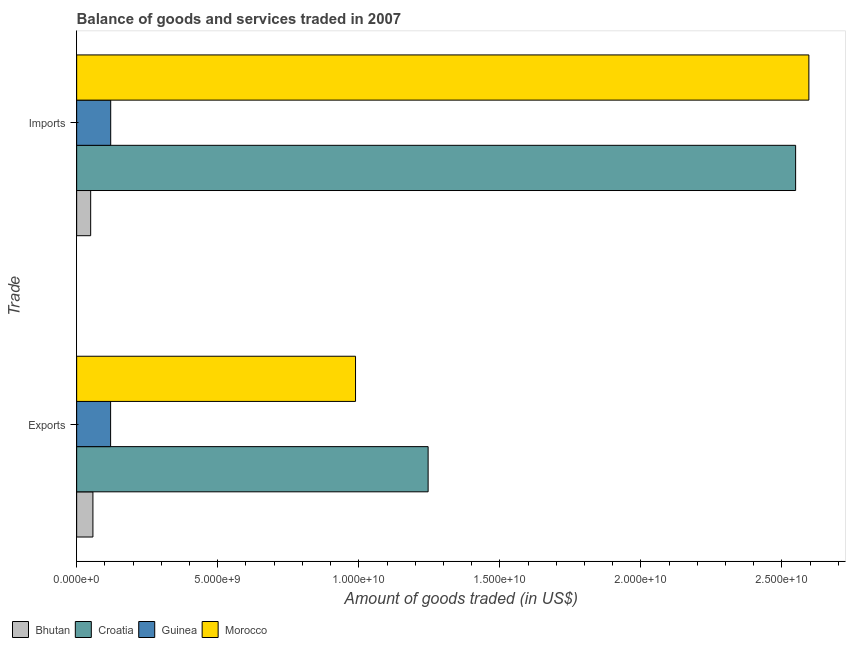How many different coloured bars are there?
Keep it short and to the point. 4. How many bars are there on the 2nd tick from the bottom?
Make the answer very short. 4. What is the label of the 1st group of bars from the top?
Provide a succinct answer. Imports. What is the amount of goods imported in Bhutan?
Make the answer very short. 4.97e+08. Across all countries, what is the maximum amount of goods exported?
Your answer should be compact. 1.25e+1. Across all countries, what is the minimum amount of goods exported?
Make the answer very short. 5.77e+08. In which country was the amount of goods imported maximum?
Provide a succinct answer. Morocco. In which country was the amount of goods imported minimum?
Keep it short and to the point. Bhutan. What is the total amount of goods imported in the graph?
Your answer should be very brief. 5.31e+1. What is the difference between the amount of goods exported in Bhutan and that in Morocco?
Your answer should be compact. -9.31e+09. What is the difference between the amount of goods imported in Guinea and the amount of goods exported in Bhutan?
Your answer should be very brief. 6.30e+08. What is the average amount of goods imported per country?
Offer a very short reply. 1.33e+1. What is the difference between the amount of goods imported and amount of goods exported in Guinea?
Your response must be concise. 3.24e+06. What is the ratio of the amount of goods imported in Guinea to that in Croatia?
Your answer should be compact. 0.05. Is the amount of goods exported in Croatia less than that in Guinea?
Ensure brevity in your answer.  No. What does the 2nd bar from the top in Exports represents?
Keep it short and to the point. Guinea. What does the 4th bar from the bottom in Exports represents?
Your answer should be very brief. Morocco. How many bars are there?
Make the answer very short. 8. How many countries are there in the graph?
Give a very brief answer. 4. What is the difference between two consecutive major ticks on the X-axis?
Your answer should be very brief. 5.00e+09. Does the graph contain grids?
Your answer should be compact. No. Where does the legend appear in the graph?
Your answer should be very brief. Bottom left. How many legend labels are there?
Keep it short and to the point. 4. What is the title of the graph?
Your response must be concise. Balance of goods and services traded in 2007. What is the label or title of the X-axis?
Ensure brevity in your answer.  Amount of goods traded (in US$). What is the label or title of the Y-axis?
Ensure brevity in your answer.  Trade. What is the Amount of goods traded (in US$) in Bhutan in Exports?
Provide a short and direct response. 5.77e+08. What is the Amount of goods traded (in US$) in Croatia in Exports?
Provide a succinct answer. 1.25e+1. What is the Amount of goods traded (in US$) of Guinea in Exports?
Offer a terse response. 1.20e+09. What is the Amount of goods traded (in US$) in Morocco in Exports?
Your answer should be very brief. 9.88e+09. What is the Amount of goods traded (in US$) in Bhutan in Imports?
Provide a succinct answer. 4.97e+08. What is the Amount of goods traded (in US$) in Croatia in Imports?
Your answer should be compact. 2.55e+1. What is the Amount of goods traded (in US$) of Guinea in Imports?
Your answer should be very brief. 1.21e+09. What is the Amount of goods traded (in US$) of Morocco in Imports?
Give a very brief answer. 2.60e+1. Across all Trade, what is the maximum Amount of goods traded (in US$) of Bhutan?
Ensure brevity in your answer.  5.77e+08. Across all Trade, what is the maximum Amount of goods traded (in US$) of Croatia?
Provide a short and direct response. 2.55e+1. Across all Trade, what is the maximum Amount of goods traded (in US$) of Guinea?
Give a very brief answer. 1.21e+09. Across all Trade, what is the maximum Amount of goods traded (in US$) of Morocco?
Your answer should be very brief. 2.60e+1. Across all Trade, what is the minimum Amount of goods traded (in US$) of Bhutan?
Offer a very short reply. 4.97e+08. Across all Trade, what is the minimum Amount of goods traded (in US$) in Croatia?
Make the answer very short. 1.25e+1. Across all Trade, what is the minimum Amount of goods traded (in US$) of Guinea?
Your answer should be compact. 1.20e+09. Across all Trade, what is the minimum Amount of goods traded (in US$) of Morocco?
Your answer should be very brief. 9.88e+09. What is the total Amount of goods traded (in US$) in Bhutan in the graph?
Your response must be concise. 1.07e+09. What is the total Amount of goods traded (in US$) of Croatia in the graph?
Offer a terse response. 3.79e+1. What is the total Amount of goods traded (in US$) in Guinea in the graph?
Offer a terse response. 2.41e+09. What is the total Amount of goods traded (in US$) in Morocco in the graph?
Your answer should be compact. 3.58e+1. What is the difference between the Amount of goods traded (in US$) of Bhutan in Exports and that in Imports?
Make the answer very short. 7.97e+07. What is the difference between the Amount of goods traded (in US$) in Croatia in Exports and that in Imports?
Your response must be concise. -1.30e+1. What is the difference between the Amount of goods traded (in US$) in Guinea in Exports and that in Imports?
Your response must be concise. -3.24e+06. What is the difference between the Amount of goods traded (in US$) in Morocco in Exports and that in Imports?
Your response must be concise. -1.61e+1. What is the difference between the Amount of goods traded (in US$) in Bhutan in Exports and the Amount of goods traded (in US$) in Croatia in Imports?
Your answer should be compact. -2.49e+1. What is the difference between the Amount of goods traded (in US$) of Bhutan in Exports and the Amount of goods traded (in US$) of Guinea in Imports?
Keep it short and to the point. -6.30e+08. What is the difference between the Amount of goods traded (in US$) of Bhutan in Exports and the Amount of goods traded (in US$) of Morocco in Imports?
Make the answer very short. -2.54e+1. What is the difference between the Amount of goods traded (in US$) of Croatia in Exports and the Amount of goods traded (in US$) of Guinea in Imports?
Offer a terse response. 1.13e+1. What is the difference between the Amount of goods traded (in US$) of Croatia in Exports and the Amount of goods traded (in US$) of Morocco in Imports?
Your response must be concise. -1.35e+1. What is the difference between the Amount of goods traded (in US$) of Guinea in Exports and the Amount of goods traded (in US$) of Morocco in Imports?
Ensure brevity in your answer.  -2.48e+1. What is the average Amount of goods traded (in US$) in Bhutan per Trade?
Offer a terse response. 5.37e+08. What is the average Amount of goods traded (in US$) in Croatia per Trade?
Offer a very short reply. 1.90e+1. What is the average Amount of goods traded (in US$) in Guinea per Trade?
Make the answer very short. 1.20e+09. What is the average Amount of goods traded (in US$) of Morocco per Trade?
Provide a short and direct response. 1.79e+1. What is the difference between the Amount of goods traded (in US$) in Bhutan and Amount of goods traded (in US$) in Croatia in Exports?
Give a very brief answer. -1.19e+1. What is the difference between the Amount of goods traded (in US$) of Bhutan and Amount of goods traded (in US$) of Guinea in Exports?
Keep it short and to the point. -6.27e+08. What is the difference between the Amount of goods traded (in US$) in Bhutan and Amount of goods traded (in US$) in Morocco in Exports?
Your response must be concise. -9.31e+09. What is the difference between the Amount of goods traded (in US$) in Croatia and Amount of goods traded (in US$) in Guinea in Exports?
Give a very brief answer. 1.13e+1. What is the difference between the Amount of goods traded (in US$) in Croatia and Amount of goods traded (in US$) in Morocco in Exports?
Give a very brief answer. 2.57e+09. What is the difference between the Amount of goods traded (in US$) of Guinea and Amount of goods traded (in US$) of Morocco in Exports?
Ensure brevity in your answer.  -8.68e+09. What is the difference between the Amount of goods traded (in US$) in Bhutan and Amount of goods traded (in US$) in Croatia in Imports?
Give a very brief answer. -2.50e+1. What is the difference between the Amount of goods traded (in US$) in Bhutan and Amount of goods traded (in US$) in Guinea in Imports?
Your answer should be very brief. -7.10e+08. What is the difference between the Amount of goods traded (in US$) in Bhutan and Amount of goods traded (in US$) in Morocco in Imports?
Provide a short and direct response. -2.55e+1. What is the difference between the Amount of goods traded (in US$) of Croatia and Amount of goods traded (in US$) of Guinea in Imports?
Offer a terse response. 2.43e+1. What is the difference between the Amount of goods traded (in US$) of Croatia and Amount of goods traded (in US$) of Morocco in Imports?
Your answer should be compact. -4.70e+08. What is the difference between the Amount of goods traded (in US$) in Guinea and Amount of goods traded (in US$) in Morocco in Imports?
Provide a short and direct response. -2.47e+1. What is the ratio of the Amount of goods traded (in US$) in Bhutan in Exports to that in Imports?
Offer a terse response. 1.16. What is the ratio of the Amount of goods traded (in US$) in Croatia in Exports to that in Imports?
Your answer should be compact. 0.49. What is the ratio of the Amount of goods traded (in US$) of Guinea in Exports to that in Imports?
Make the answer very short. 1. What is the ratio of the Amount of goods traded (in US$) of Morocco in Exports to that in Imports?
Ensure brevity in your answer.  0.38. What is the difference between the highest and the second highest Amount of goods traded (in US$) of Bhutan?
Provide a short and direct response. 7.97e+07. What is the difference between the highest and the second highest Amount of goods traded (in US$) in Croatia?
Provide a succinct answer. 1.30e+1. What is the difference between the highest and the second highest Amount of goods traded (in US$) of Guinea?
Your response must be concise. 3.24e+06. What is the difference between the highest and the second highest Amount of goods traded (in US$) of Morocco?
Keep it short and to the point. 1.61e+1. What is the difference between the highest and the lowest Amount of goods traded (in US$) in Bhutan?
Keep it short and to the point. 7.97e+07. What is the difference between the highest and the lowest Amount of goods traded (in US$) of Croatia?
Provide a short and direct response. 1.30e+1. What is the difference between the highest and the lowest Amount of goods traded (in US$) of Guinea?
Provide a succinct answer. 3.24e+06. What is the difference between the highest and the lowest Amount of goods traded (in US$) of Morocco?
Your answer should be very brief. 1.61e+1. 